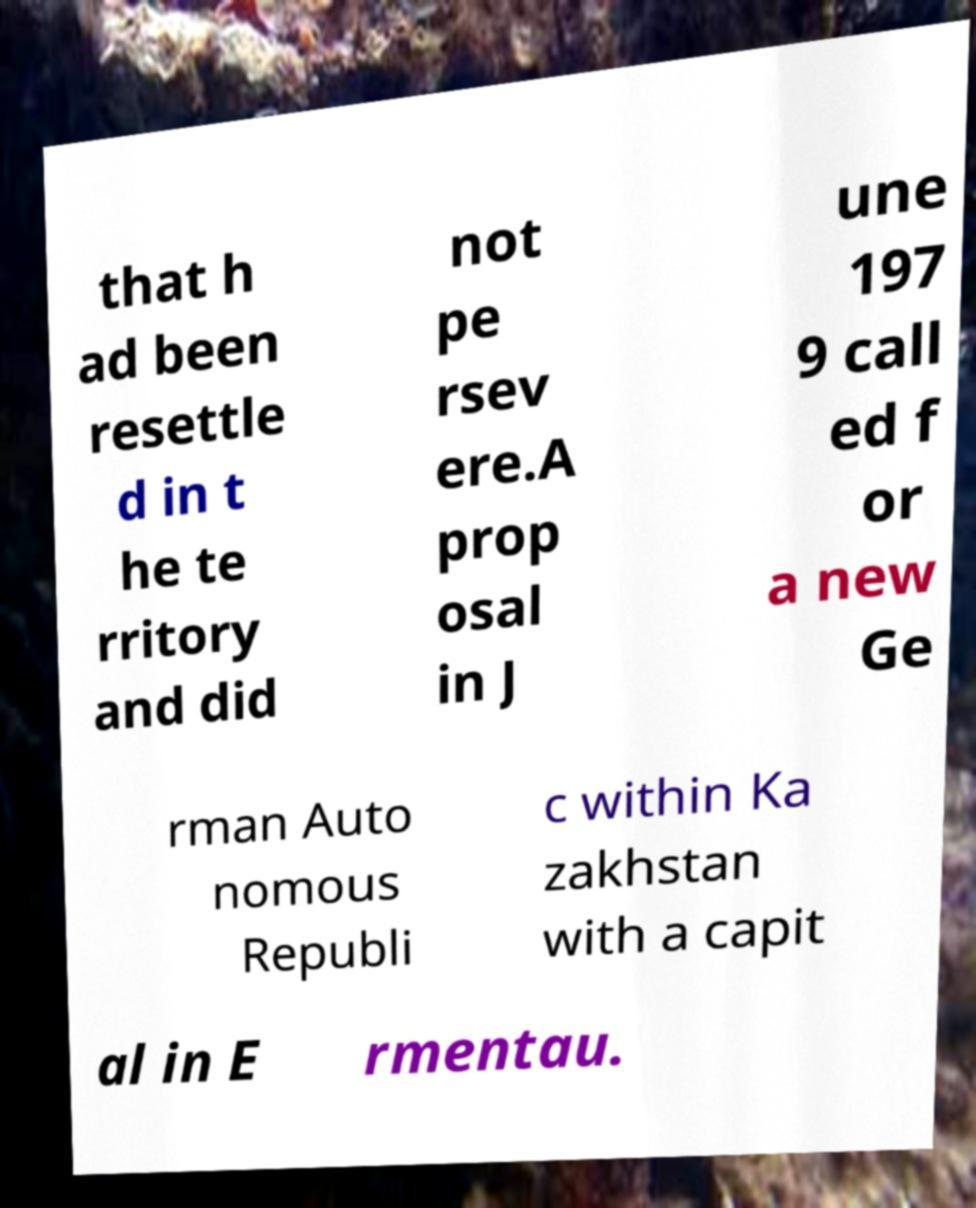Please read and relay the text visible in this image. What does it say? that h ad been resettle d in t he te rritory and did not pe rsev ere.A prop osal in J une 197 9 call ed f or a new Ge rman Auto nomous Republi c within Ka zakhstan with a capit al in E rmentau. 